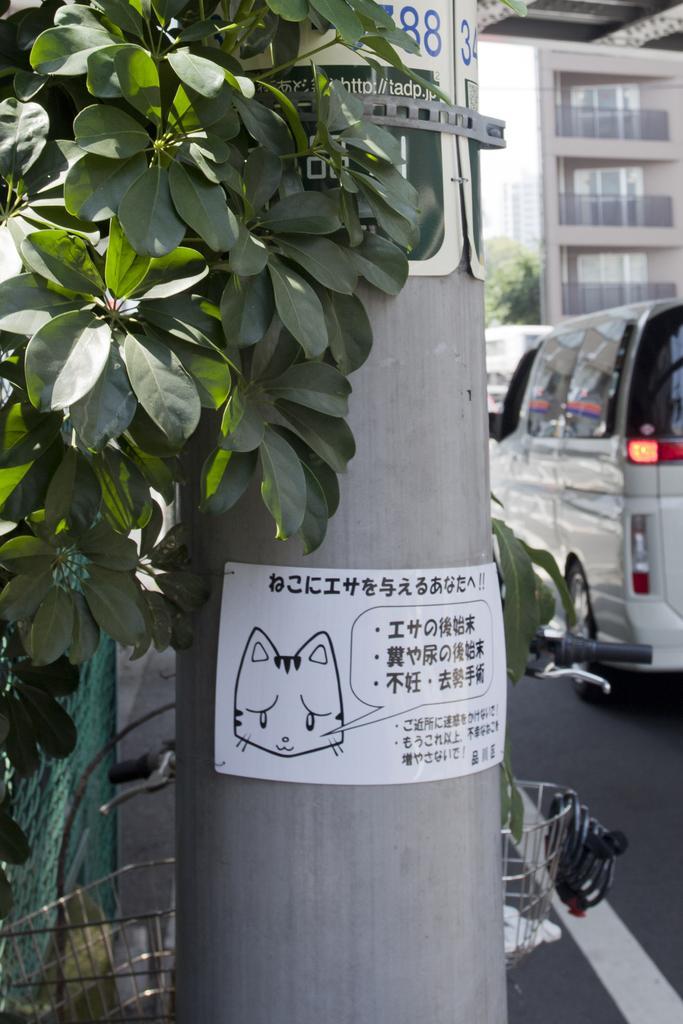In one or two sentences, can you explain what this image depicts? On the left side there are trees, in the middle there is a sticker pasted to this pole. On the right side a white color vehicle is moving on the road and there is a building in this image. 